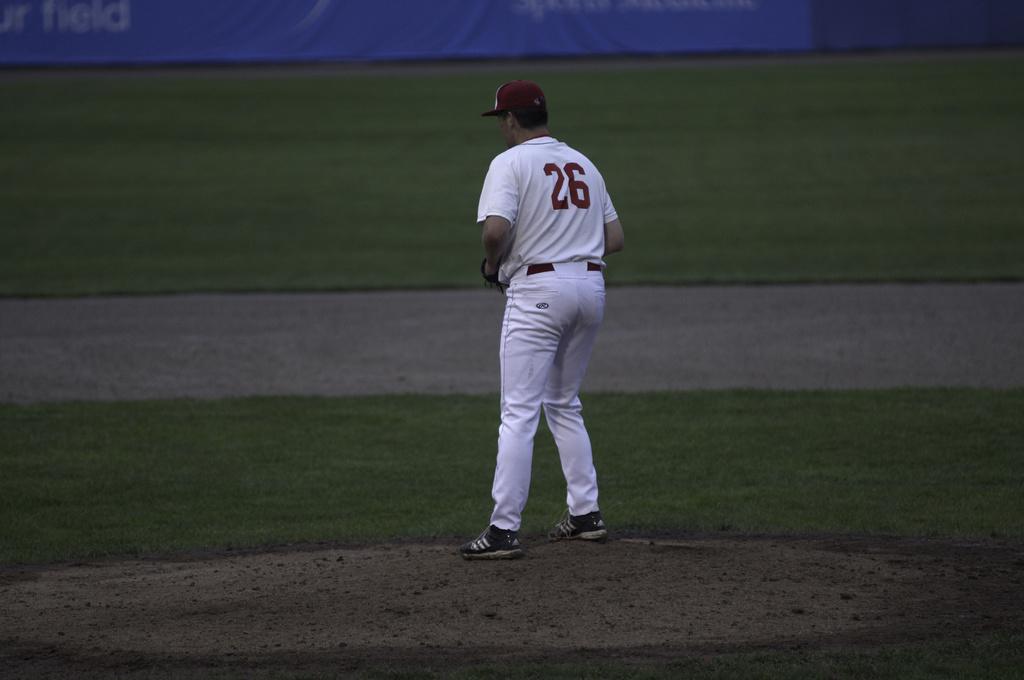What number shirt is this baseball player wearing?
Offer a terse response. 26. What game is the player playing?
Offer a very short reply. Answering does not require reading text in the image. 